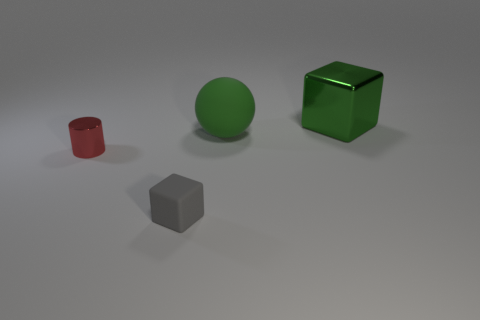What is the shape of the other big thing that is the same color as the large metal object?
Give a very brief answer. Sphere. What is the color of the cube that is in front of the large green object that is behind the big green matte ball?
Provide a short and direct response. Gray. There is a tiny thing that is the same shape as the large shiny object; what color is it?
Keep it short and to the point. Gray. What is the size of the other metal thing that is the same shape as the tiny gray object?
Offer a terse response. Large. There is a cube to the right of the tiny gray rubber object; what is it made of?
Provide a succinct answer. Metal. Is the number of tiny red metallic cylinders that are to the right of the big green matte object less than the number of large purple balls?
Keep it short and to the point. No. What is the shape of the metal thing to the left of the block in front of the green metallic thing?
Give a very brief answer. Cylinder. The cylinder is what color?
Your answer should be compact. Red. How many other things are the same size as the green metallic thing?
Make the answer very short. 1. There is a thing that is on the left side of the large green metallic block and on the right side of the tiny gray matte cube; what is it made of?
Provide a succinct answer. Rubber. 